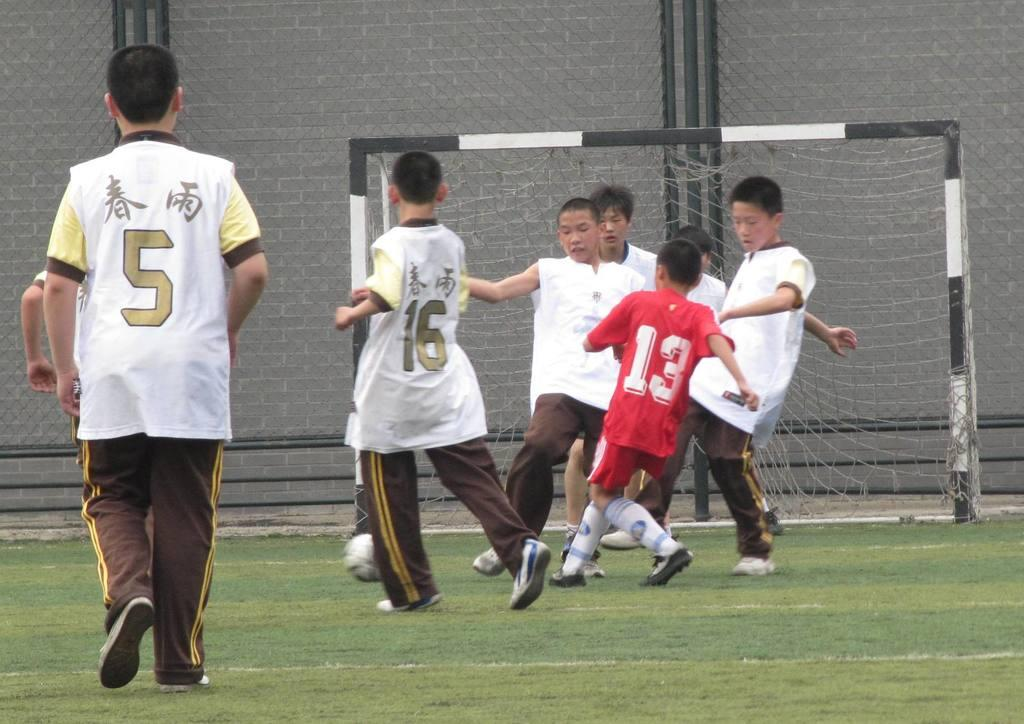<image>
Summarize the visual content of the image. soccer players in number jerseys like 16 and 13 in the midst of a game 